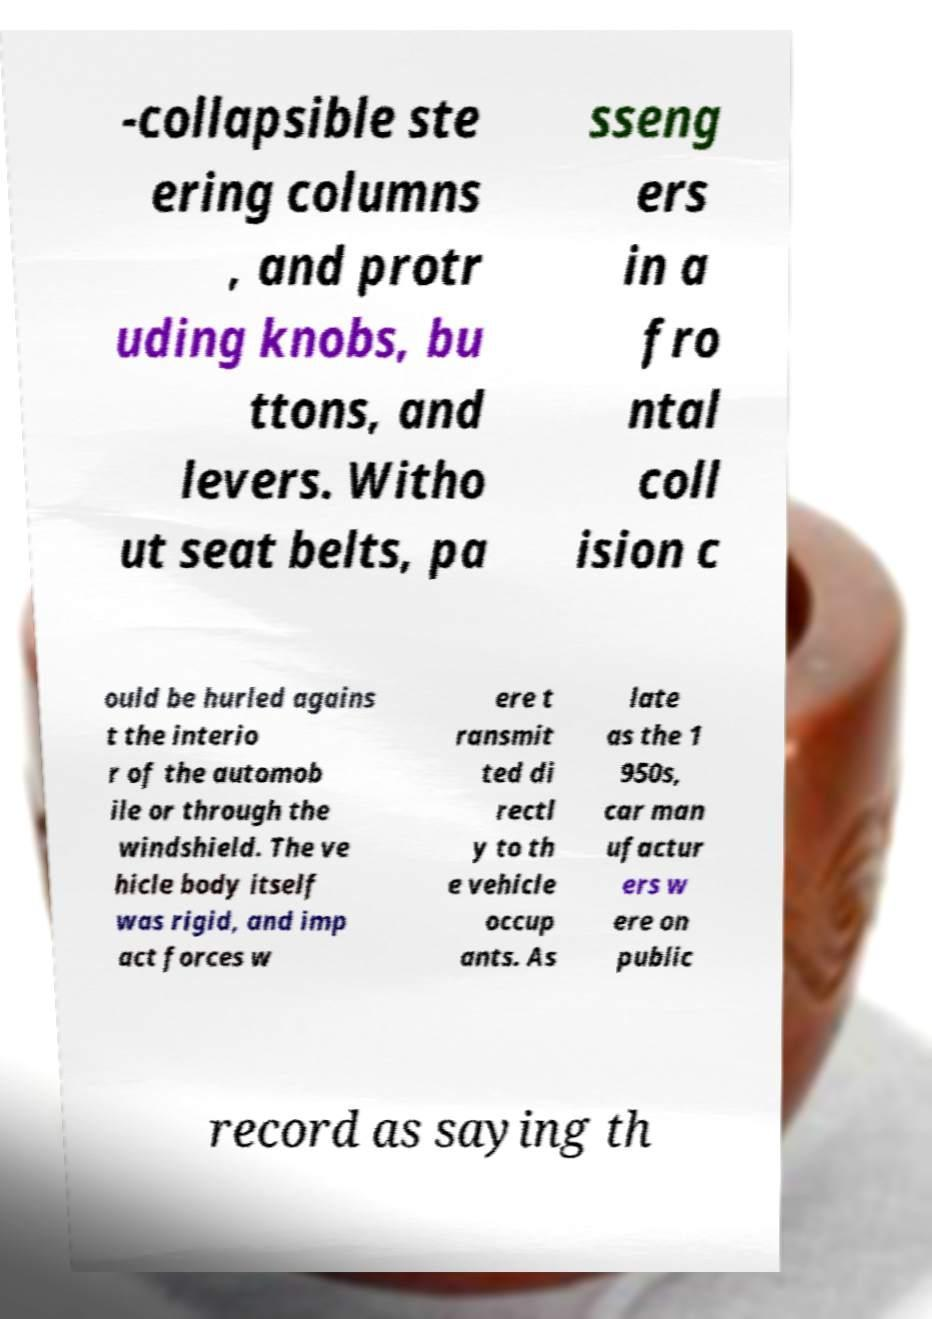Could you assist in decoding the text presented in this image and type it out clearly? -collapsible ste ering columns , and protr uding knobs, bu ttons, and levers. Witho ut seat belts, pa sseng ers in a fro ntal coll ision c ould be hurled agains t the interio r of the automob ile or through the windshield. The ve hicle body itself was rigid, and imp act forces w ere t ransmit ted di rectl y to th e vehicle occup ants. As late as the 1 950s, car man ufactur ers w ere on public record as saying th 